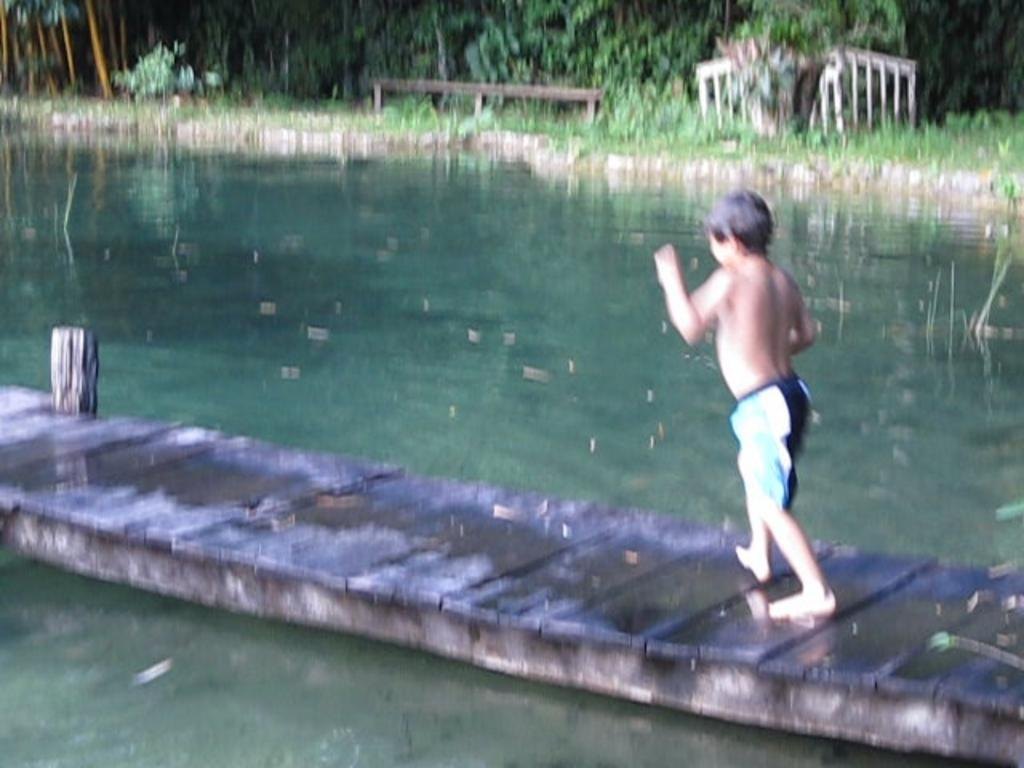Who is the main subject in the image? There is a boy in the image. What is the boy doing in the image? The boy is walking on a platform. What can be seen in the background of the image? There are objects in the background of the image. What is the natural element visible in the image? There is water visible in the image. How many rings can be seen on the boy's fingers in the image? There are no rings visible on the boy's fingers in the image. What type of thrill can be experienced by the boy in the image? The image does not provide information about any thrilling experience the boy might be having. 